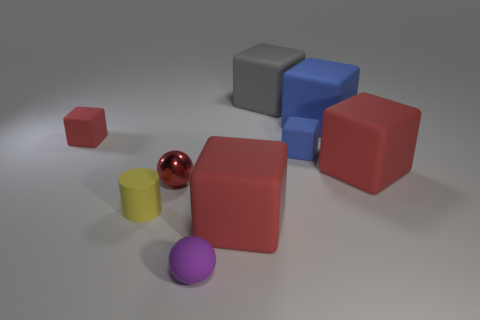Subtract all tiny rubber blocks. How many blocks are left? 4 Subtract all red cubes. How many cubes are left? 3 Subtract 2 spheres. How many spheres are left? 0 Subtract all cylinders. How many objects are left? 8 Add 1 yellow rubber cylinders. How many objects exist? 10 Subtract all green blocks. How many red spheres are left? 1 Subtract all small green metal things. Subtract all gray matte cubes. How many objects are left? 8 Add 1 big things. How many big things are left? 5 Add 7 matte cylinders. How many matte cylinders exist? 8 Subtract 0 purple cubes. How many objects are left? 9 